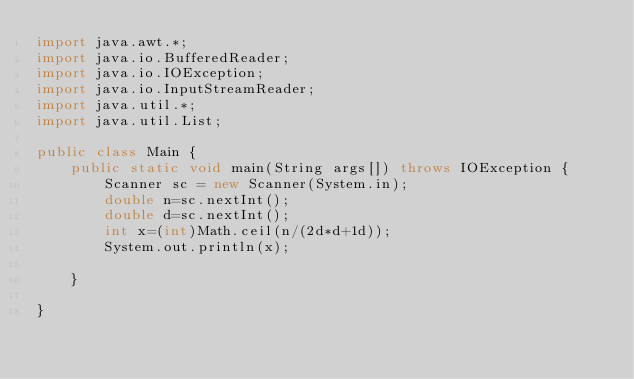<code> <loc_0><loc_0><loc_500><loc_500><_Java_>import java.awt.*;
import java.io.BufferedReader;
import java.io.IOException;
import java.io.InputStreamReader;
import java.util.*;
import java.util.List;

public class Main {
    public static void main(String args[]) throws IOException {
        Scanner sc = new Scanner(System.in);
        double n=sc.nextInt();
        double d=sc.nextInt();
        int x=(int)Math.ceil(n/(2d*d+1d));
        System.out.println(x);

    }

}

</code> 